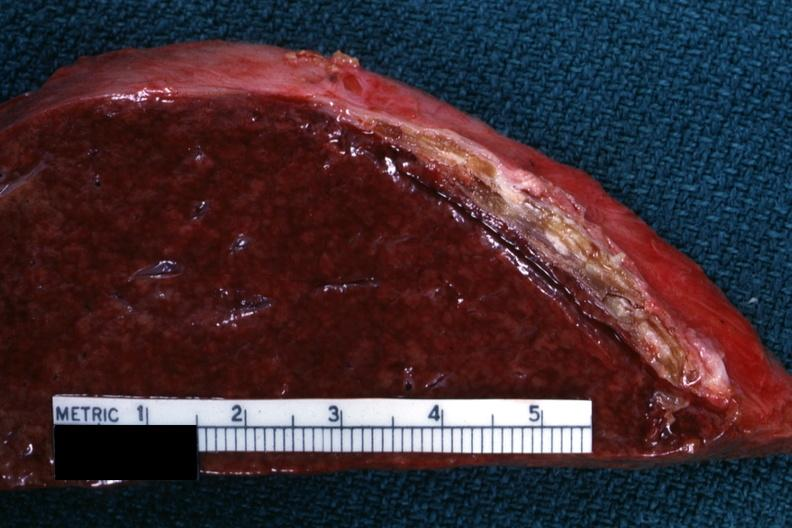what does this image show?
Answer the question using a single word or phrase. Cut surface showing very thickened capsule with focal calcification very good close-up photo 